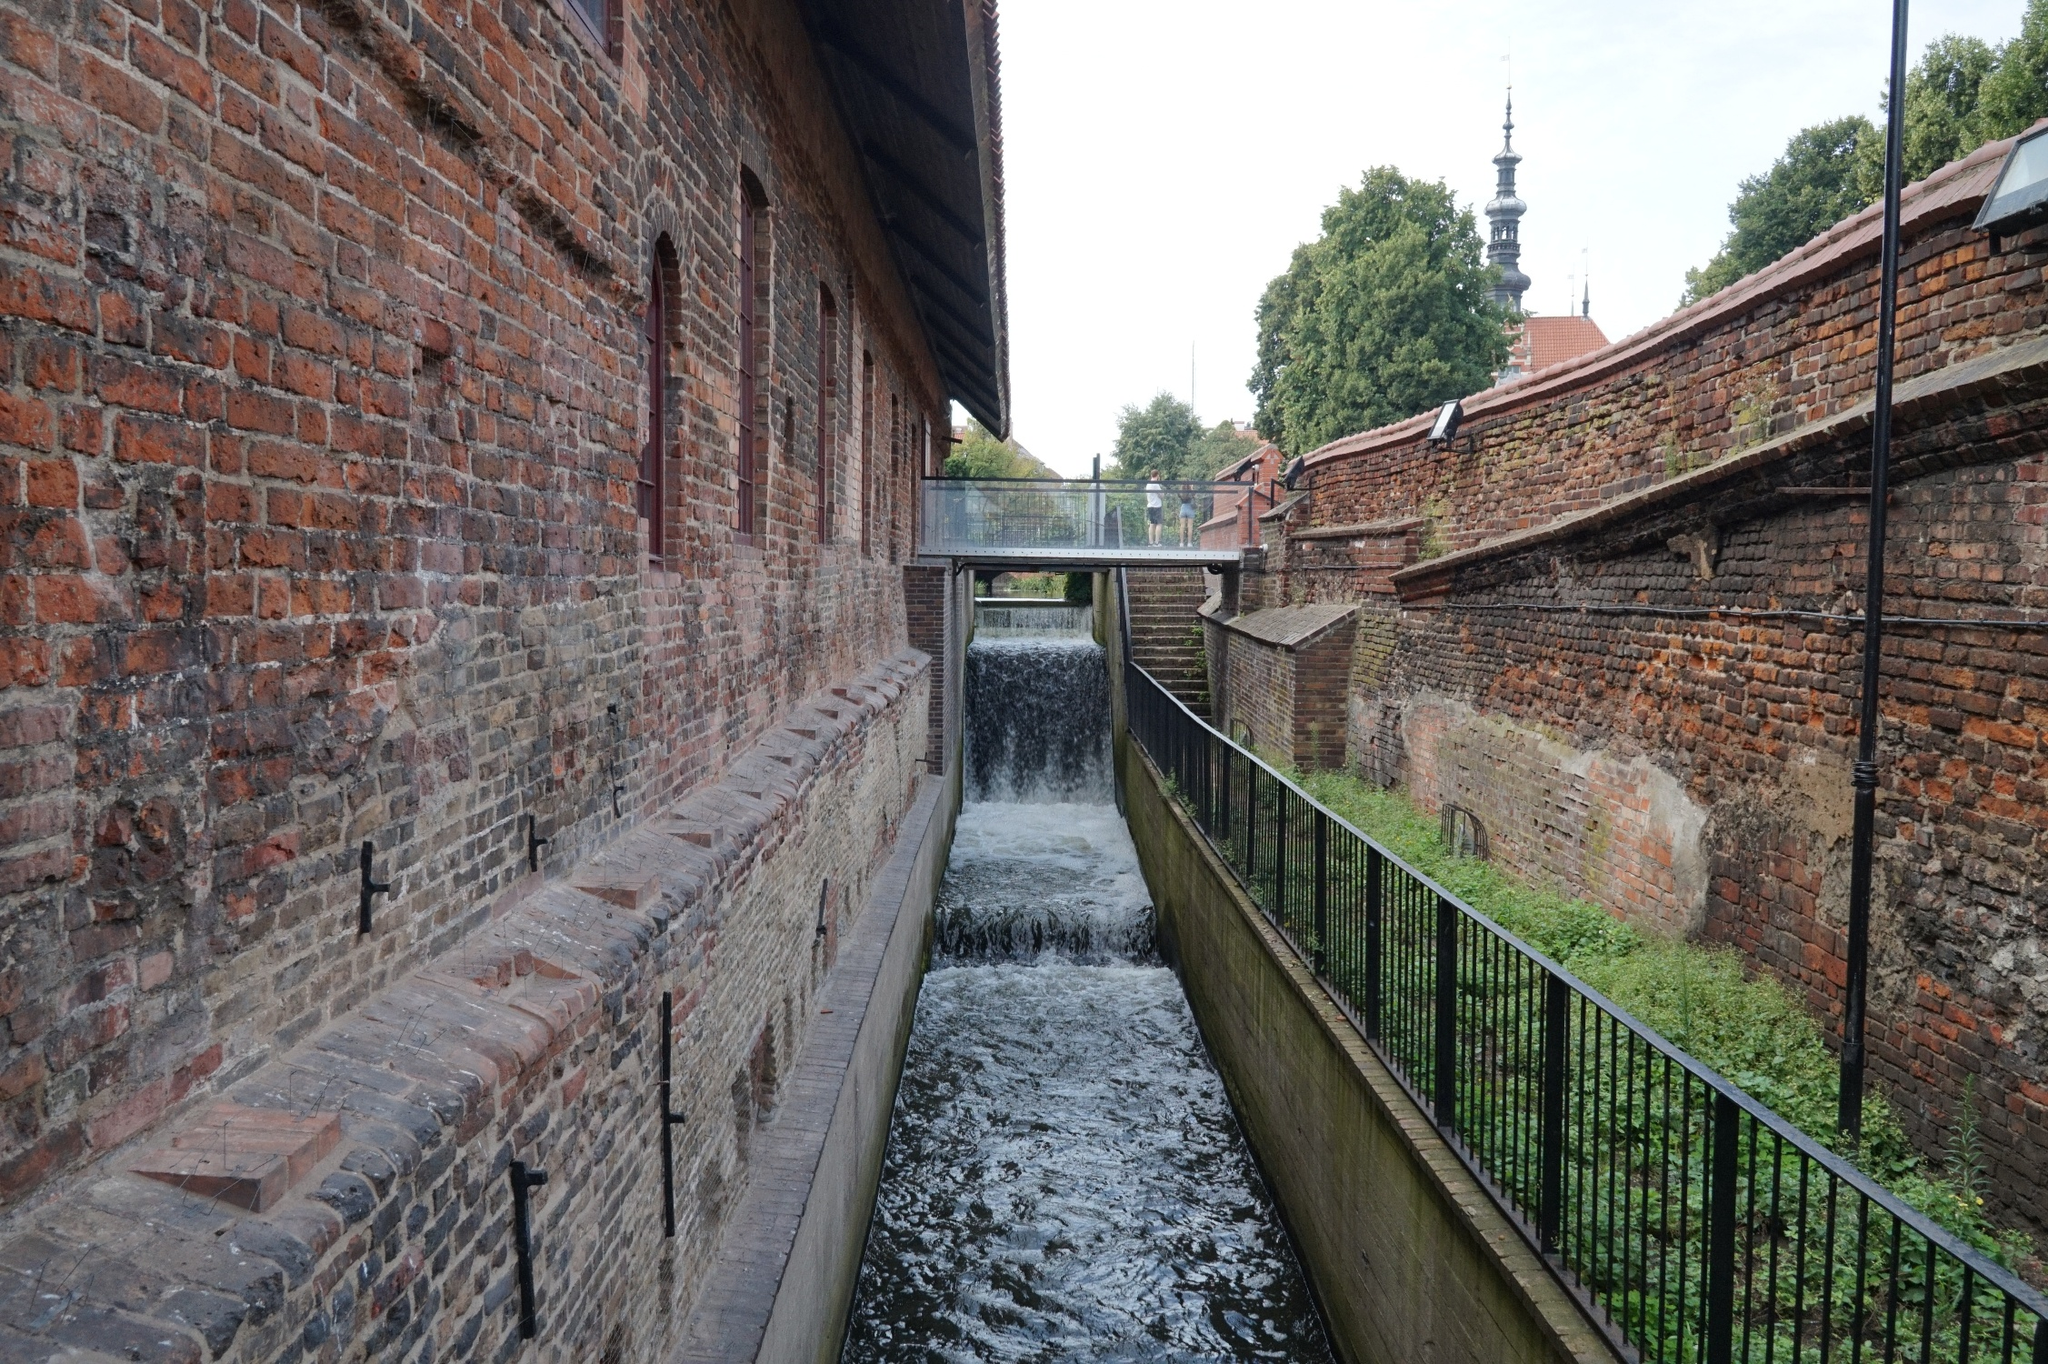What is this photo about? The image captures a serene scene in an urban setting. On the left, there's a charming brick building with a wooden roof and a prominent brick chimney, which adds a rustic touch. Extending from its side is a well-trodden wooden walkway that hovers above a narrow canal. The canal, bordered by brick walls, features a small yet lively waterfall pouring into the otherwise serene water below.

Further in the background, behind the focal point of the brick building and the canal, the spire of a church rises above the trees, hinting at a historical and architectural richness in the area. The church spire, although partially obscured by trees, conveys a traditional design and adds to the setting's intrigue. Overall, the image presents a cohesive blend of urban architecture and natural elements, creating an inviting and picturesque scene. 